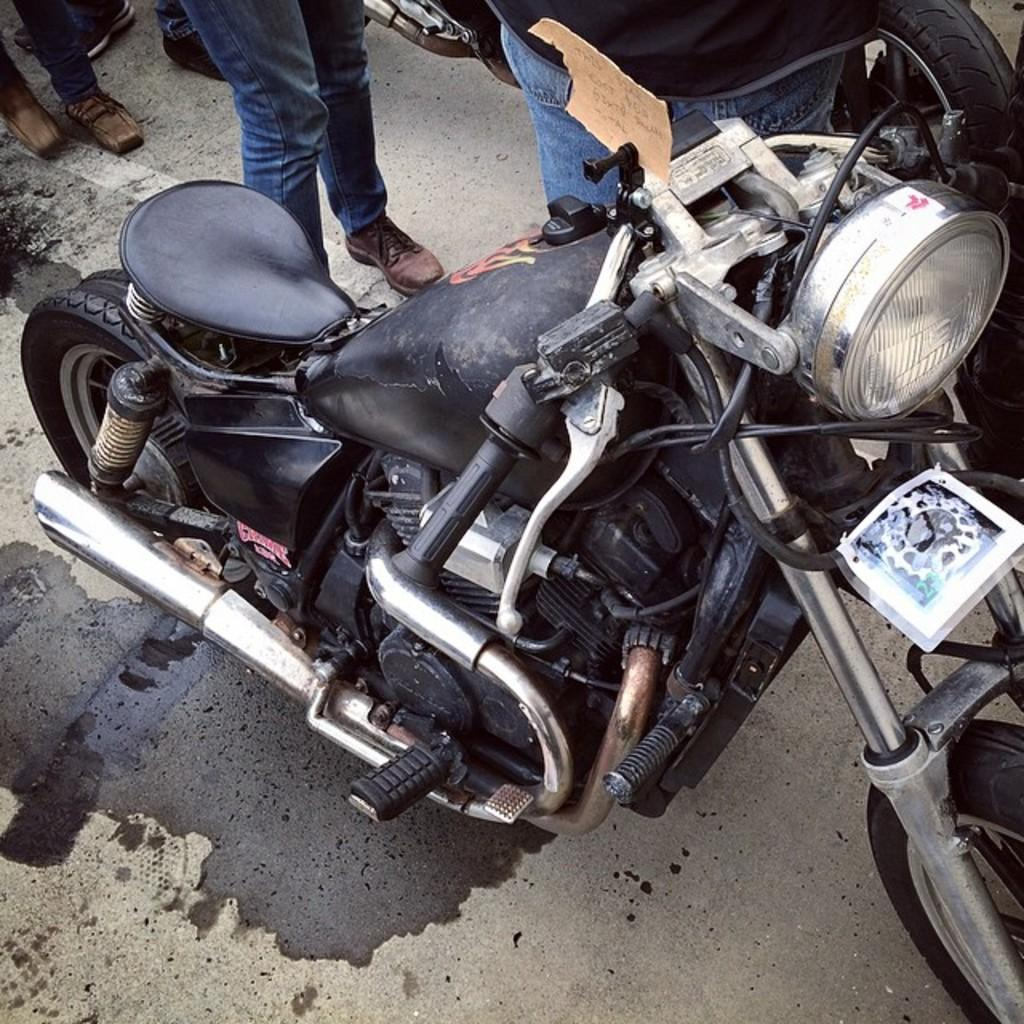What is the main subject of the image? The main subject of the image is a motorbike. Can you describe the setting of the image? There are people in the background of the image, and a road is visible at the bottom. What type of potato is being played by the band in the image? There is no band or potato present in the image; it features a motorbike and people in the background. 